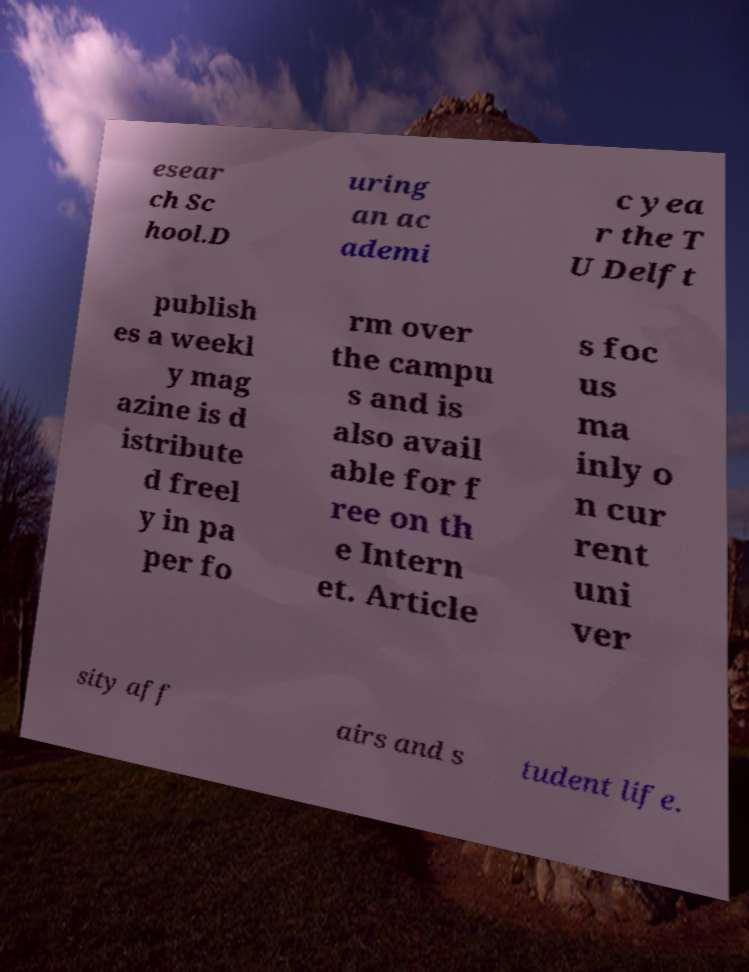Can you accurately transcribe the text from the provided image for me? esear ch Sc hool.D uring an ac ademi c yea r the T U Delft publish es a weekl y mag azine is d istribute d freel y in pa per fo rm over the campu s and is also avail able for f ree on th e Intern et. Article s foc us ma inly o n cur rent uni ver sity aff airs and s tudent life. 